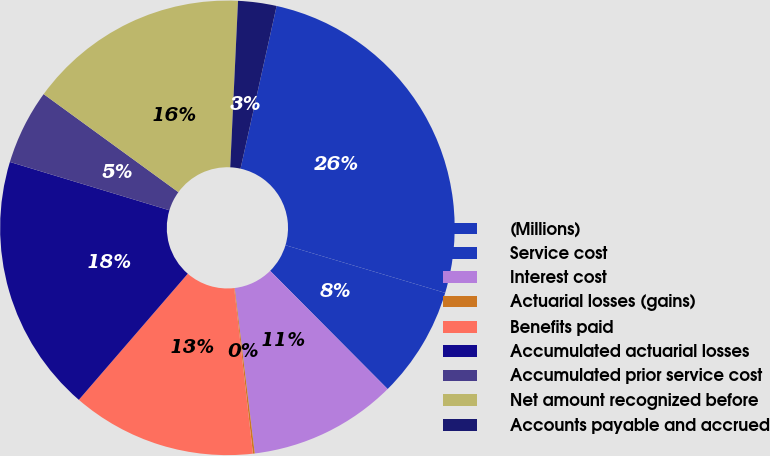Convert chart to OTSL. <chart><loc_0><loc_0><loc_500><loc_500><pie_chart><fcel>(Millions)<fcel>Service cost<fcel>Interest cost<fcel>Actuarial losses (gains)<fcel>Benefits paid<fcel>Accumulated actuarial losses<fcel>Accumulated prior service cost<fcel>Net amount recognized before<fcel>Accounts payable and accrued<nl><fcel>26.14%<fcel>7.93%<fcel>10.53%<fcel>0.13%<fcel>13.13%<fcel>18.34%<fcel>5.33%<fcel>15.73%<fcel>2.73%<nl></chart> 